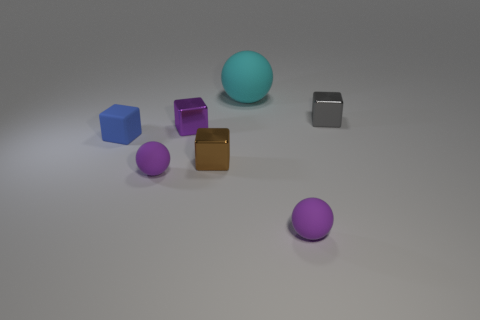Subtract all purple metal blocks. How many blocks are left? 3 Subtract all yellow cubes. How many purple spheres are left? 2 Add 3 brown shiny cylinders. How many objects exist? 10 Subtract 2 cubes. How many cubes are left? 2 Subtract all brown blocks. How many blocks are left? 3 Subtract all blocks. How many objects are left? 3 Subtract all cyan balls. Subtract all purple blocks. How many balls are left? 2 Subtract all small purple matte balls. Subtract all small rubber blocks. How many objects are left? 4 Add 5 gray metal blocks. How many gray metal blocks are left? 6 Add 7 big purple shiny balls. How many big purple shiny balls exist? 7 